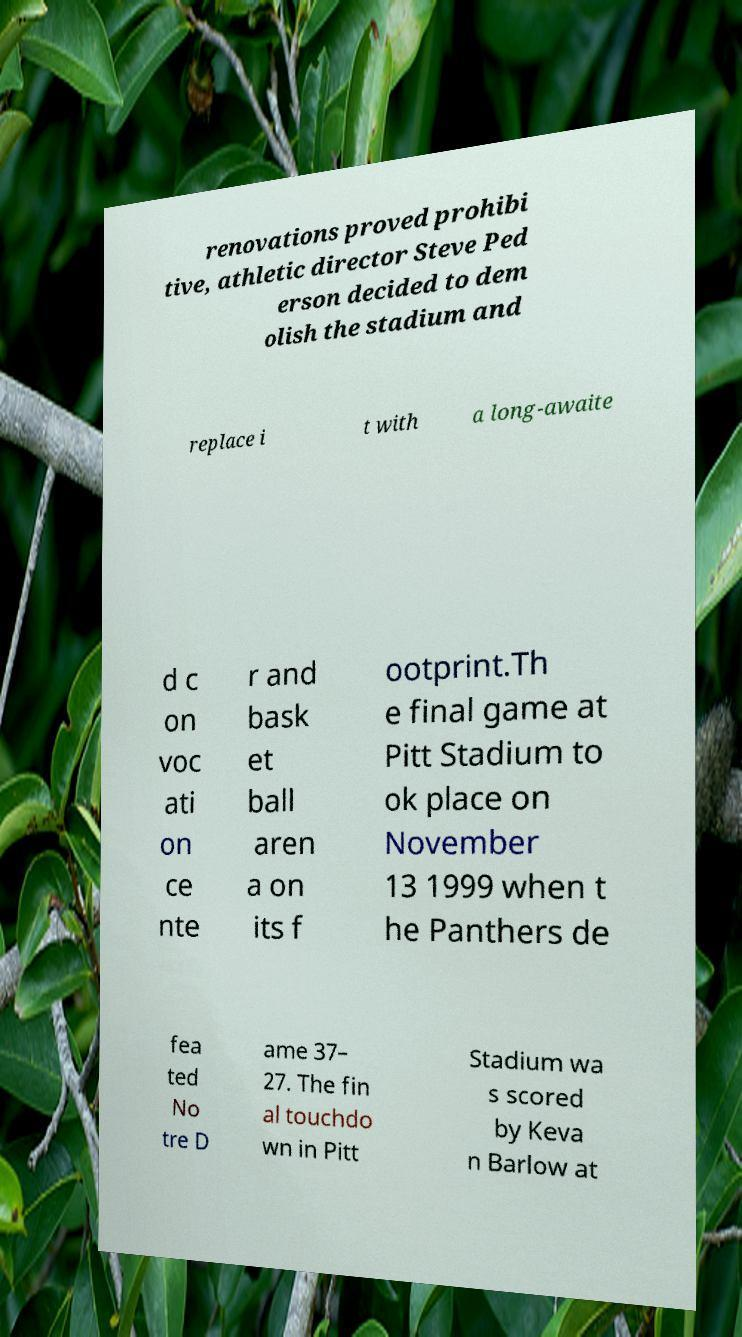Could you assist in decoding the text presented in this image and type it out clearly? renovations proved prohibi tive, athletic director Steve Ped erson decided to dem olish the stadium and replace i t with a long-awaite d c on voc ati on ce nte r and bask et ball aren a on its f ootprint.Th e final game at Pitt Stadium to ok place on November 13 1999 when t he Panthers de fea ted No tre D ame 37– 27. The fin al touchdo wn in Pitt Stadium wa s scored by Keva n Barlow at 